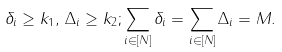<formula> <loc_0><loc_0><loc_500><loc_500>\delta _ { i } \geq k _ { 1 } , \, \Delta _ { i } \geq k _ { 2 } ; \sum _ { i \in [ N ] } \delta _ { i } = \sum _ { i \in [ N ] } \Delta _ { i } = M .</formula> 